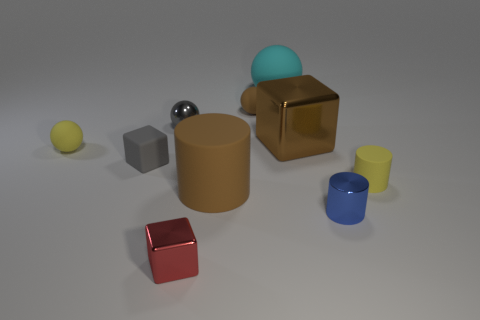Do the tiny red block and the big cyan sphere have the same material?
Make the answer very short. No. What shape is the red thing that is the same size as the matte cube?
Provide a succinct answer. Cube. Is the number of rubber cubes greater than the number of tiny cylinders?
Provide a short and direct response. No. There is a small thing that is both right of the large brown cylinder and behind the small yellow rubber ball; what is it made of?
Keep it short and to the point. Rubber. How many other things are the same material as the red cube?
Provide a short and direct response. 3. How many large metallic cubes have the same color as the small metal cylinder?
Offer a terse response. 0. There is a yellow matte thing in front of the tiny yellow object that is to the left of the small matte sphere that is on the right side of the gray metal ball; what is its size?
Your answer should be very brief. Small. What number of matte things are either tiny brown things or big green blocks?
Offer a terse response. 1. Does the tiny brown thing have the same shape as the small yellow thing that is left of the metal cylinder?
Ensure brevity in your answer.  Yes. Is the number of large spheres in front of the tiny brown sphere greater than the number of spheres on the left side of the big block?
Keep it short and to the point. No. 